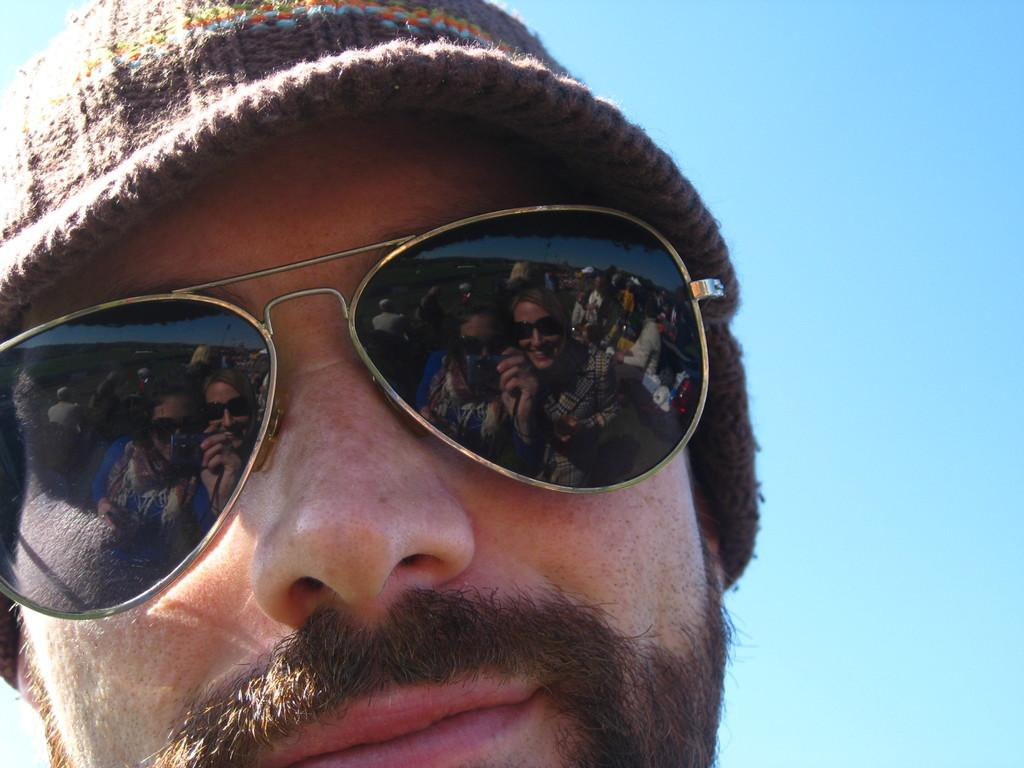Who is present in the image? There is a man in the image. What protective gear is the man wearing? The man is wearing goggles. What type of headwear is the man wearing? The man is wearing a hat. What can be seen in the background of the image? The blue sky is visible in the image. How does the man express disgust in the image? There is no indication of the man expressing disgust in the image. 